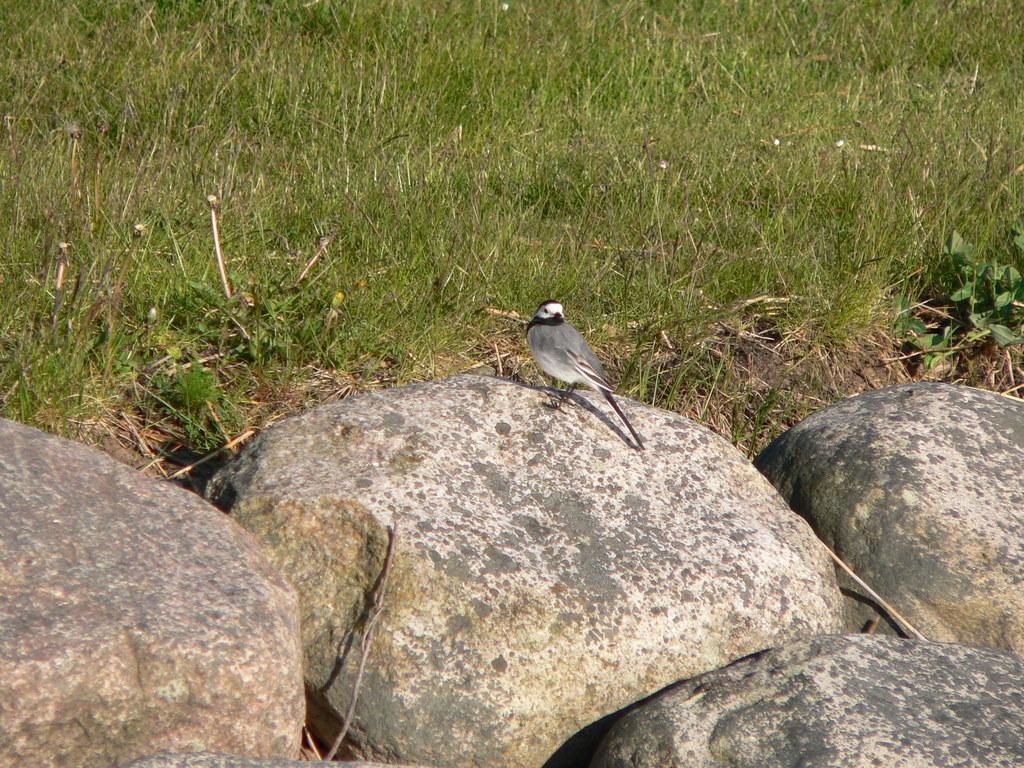Could you give a brief overview of what you see in this image? In the picture I can see a bird is standing on a rock. In the background I can see the grass and rocks. 